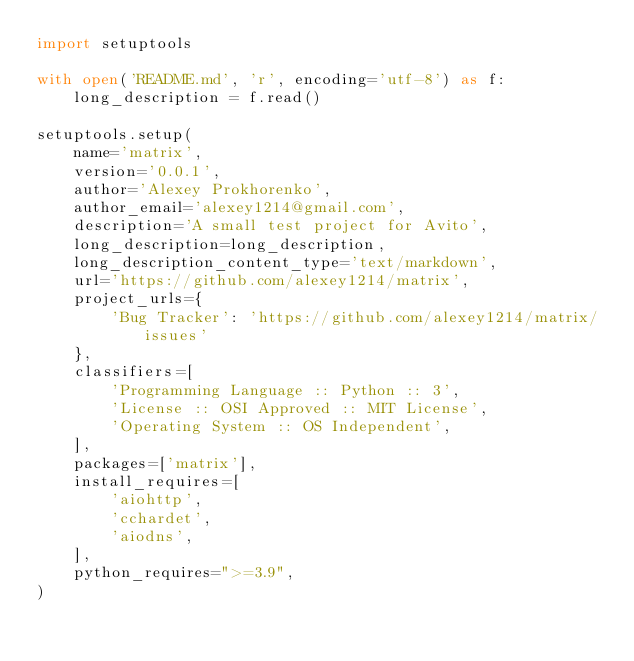<code> <loc_0><loc_0><loc_500><loc_500><_Python_>import setuptools

with open('README.md', 'r', encoding='utf-8') as f:
    long_description = f.read()

setuptools.setup(
    name='matrix',
    version='0.0.1',
    author='Alexey Prokhorenko',
    author_email='alexey1214@gmail.com',
    description='A small test project for Avito',
    long_description=long_description,
    long_description_content_type='text/markdown',
    url='https://github.com/alexey1214/matrix',
    project_urls={
        'Bug Tracker': 'https://github.com/alexey1214/matrix/issues'
    },
    classifiers=[
        'Programming Language :: Python :: 3',
        'License :: OSI Approved :: MIT License',
        'Operating System :: OS Independent',
    ],
    packages=['matrix'],
    install_requires=[
        'aiohttp',
        'cchardet',
        'aiodns',
    ],
    python_requires=">=3.9",
)</code> 